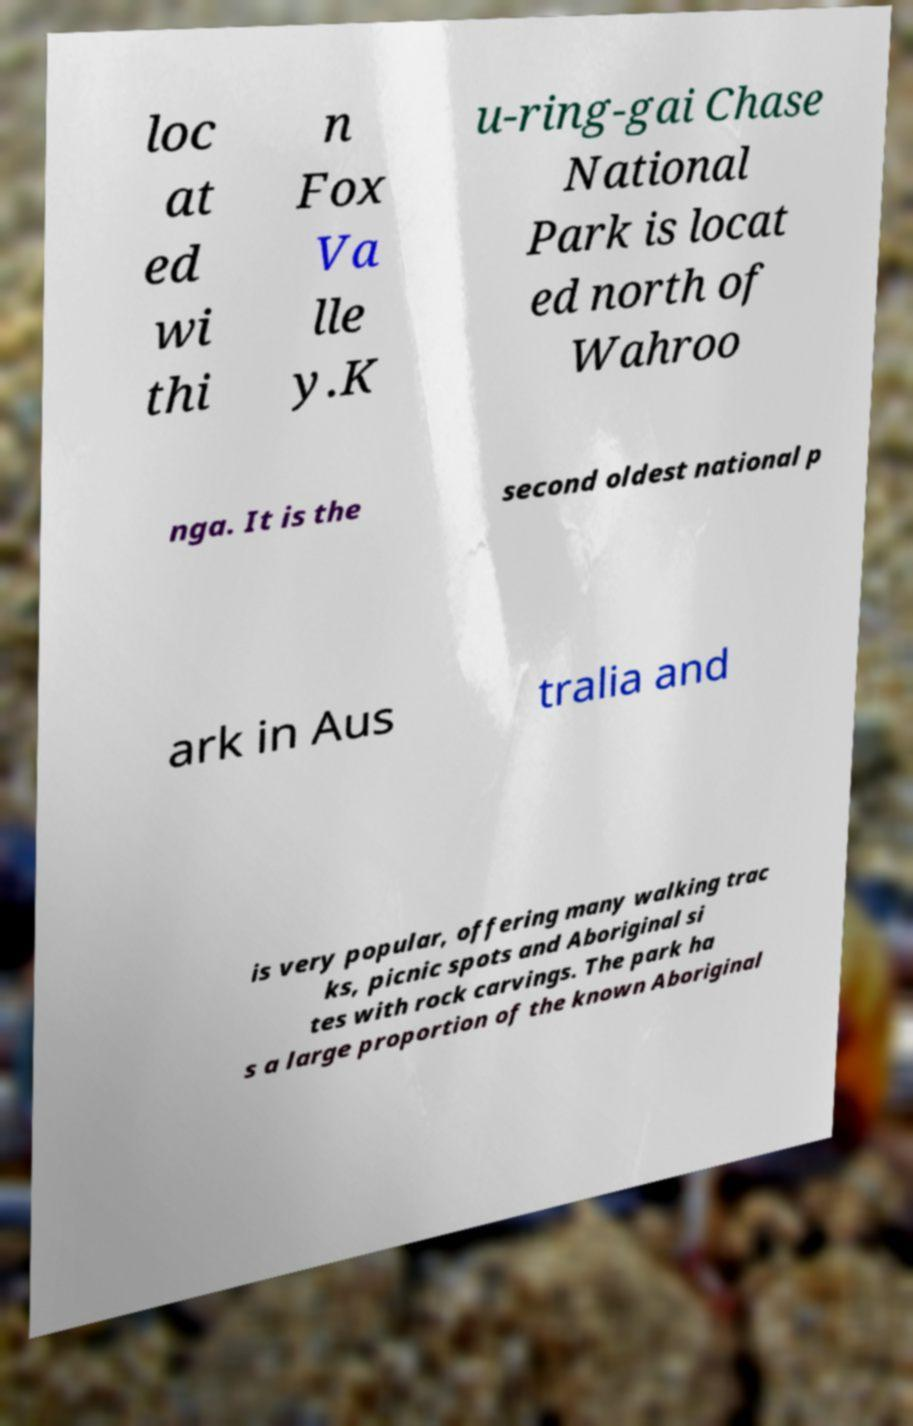I need the written content from this picture converted into text. Can you do that? loc at ed wi thi n Fox Va lle y.K u-ring-gai Chase National Park is locat ed north of Wahroo nga. It is the second oldest national p ark in Aus tralia and is very popular, offering many walking trac ks, picnic spots and Aboriginal si tes with rock carvings. The park ha s a large proportion of the known Aboriginal 